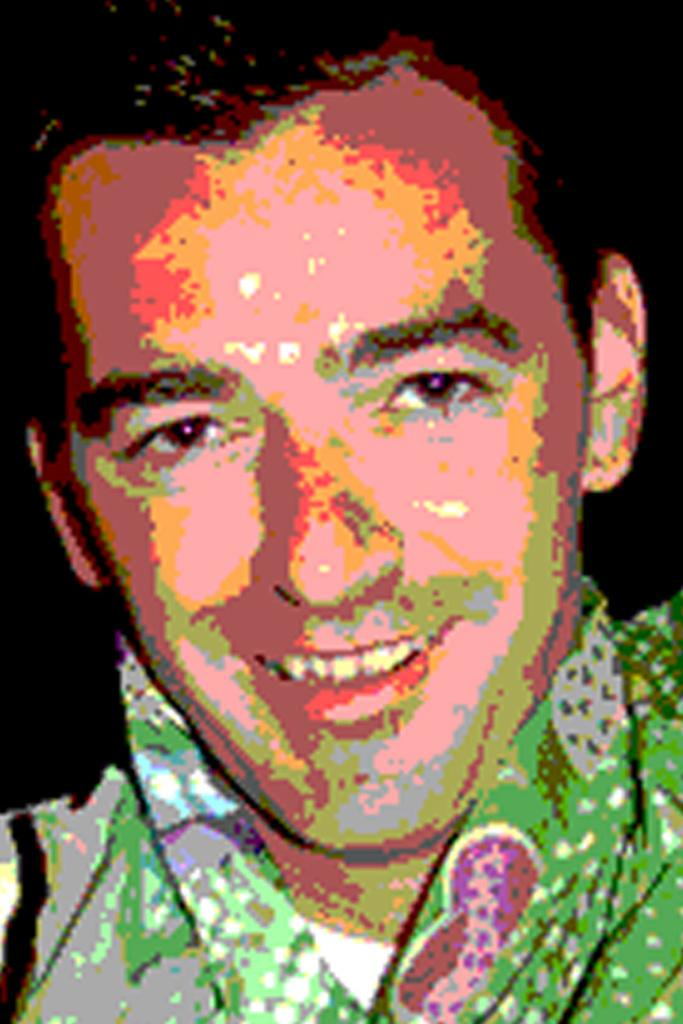Who is present in the image? There is a man in the image. What can be observed about the background of the image? The background of the image is dark. What type of card is the man holding in the image? There is no card present in the image; only the man and the dark background can be observed. 